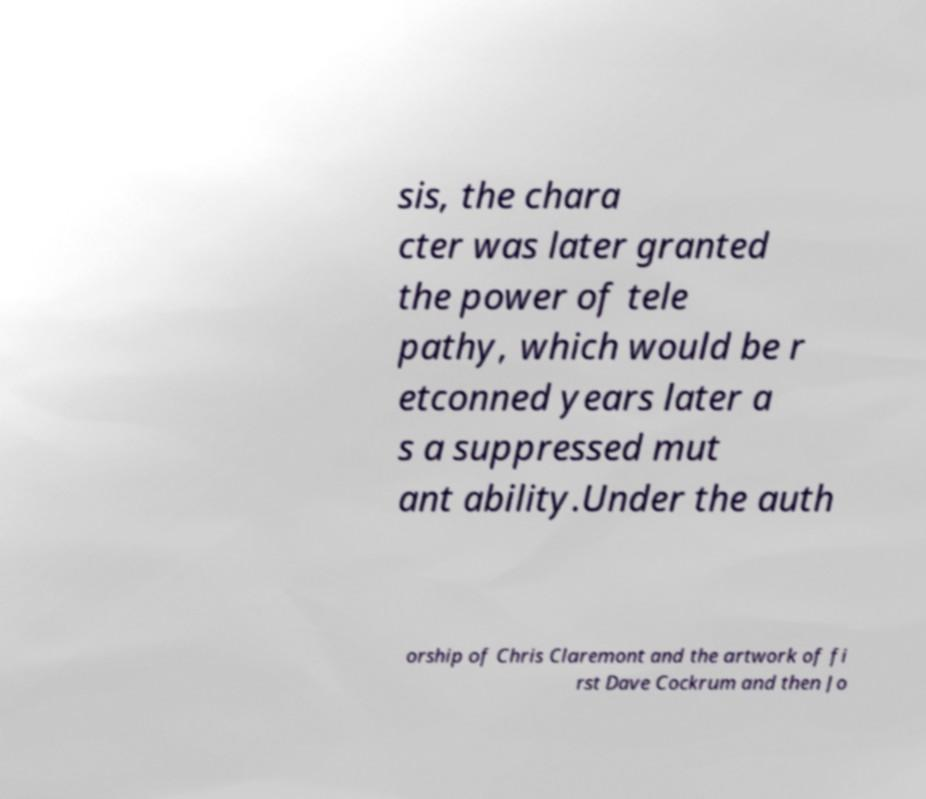Please read and relay the text visible in this image. What does it say? sis, the chara cter was later granted the power of tele pathy, which would be r etconned years later a s a suppressed mut ant ability.Under the auth orship of Chris Claremont and the artwork of fi rst Dave Cockrum and then Jo 